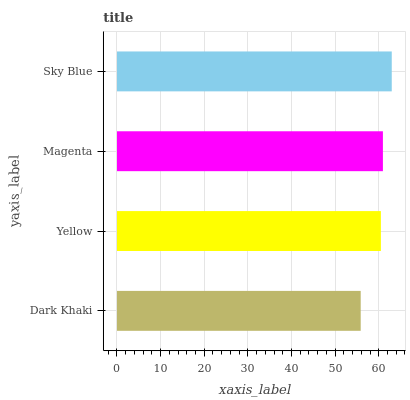Is Dark Khaki the minimum?
Answer yes or no. Yes. Is Sky Blue the maximum?
Answer yes or no. Yes. Is Yellow the minimum?
Answer yes or no. No. Is Yellow the maximum?
Answer yes or no. No. Is Yellow greater than Dark Khaki?
Answer yes or no. Yes. Is Dark Khaki less than Yellow?
Answer yes or no. Yes. Is Dark Khaki greater than Yellow?
Answer yes or no. No. Is Yellow less than Dark Khaki?
Answer yes or no. No. Is Magenta the high median?
Answer yes or no. Yes. Is Yellow the low median?
Answer yes or no. Yes. Is Sky Blue the high median?
Answer yes or no. No. Is Sky Blue the low median?
Answer yes or no. No. 